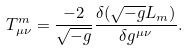<formula> <loc_0><loc_0><loc_500><loc_500>T ^ { m } _ { \mu \nu } = \frac { - 2 } { \sqrt { - g } } \frac { \delta ( \sqrt { - g } L _ { m } ) } { \delta g ^ { \mu \nu } } .</formula> 